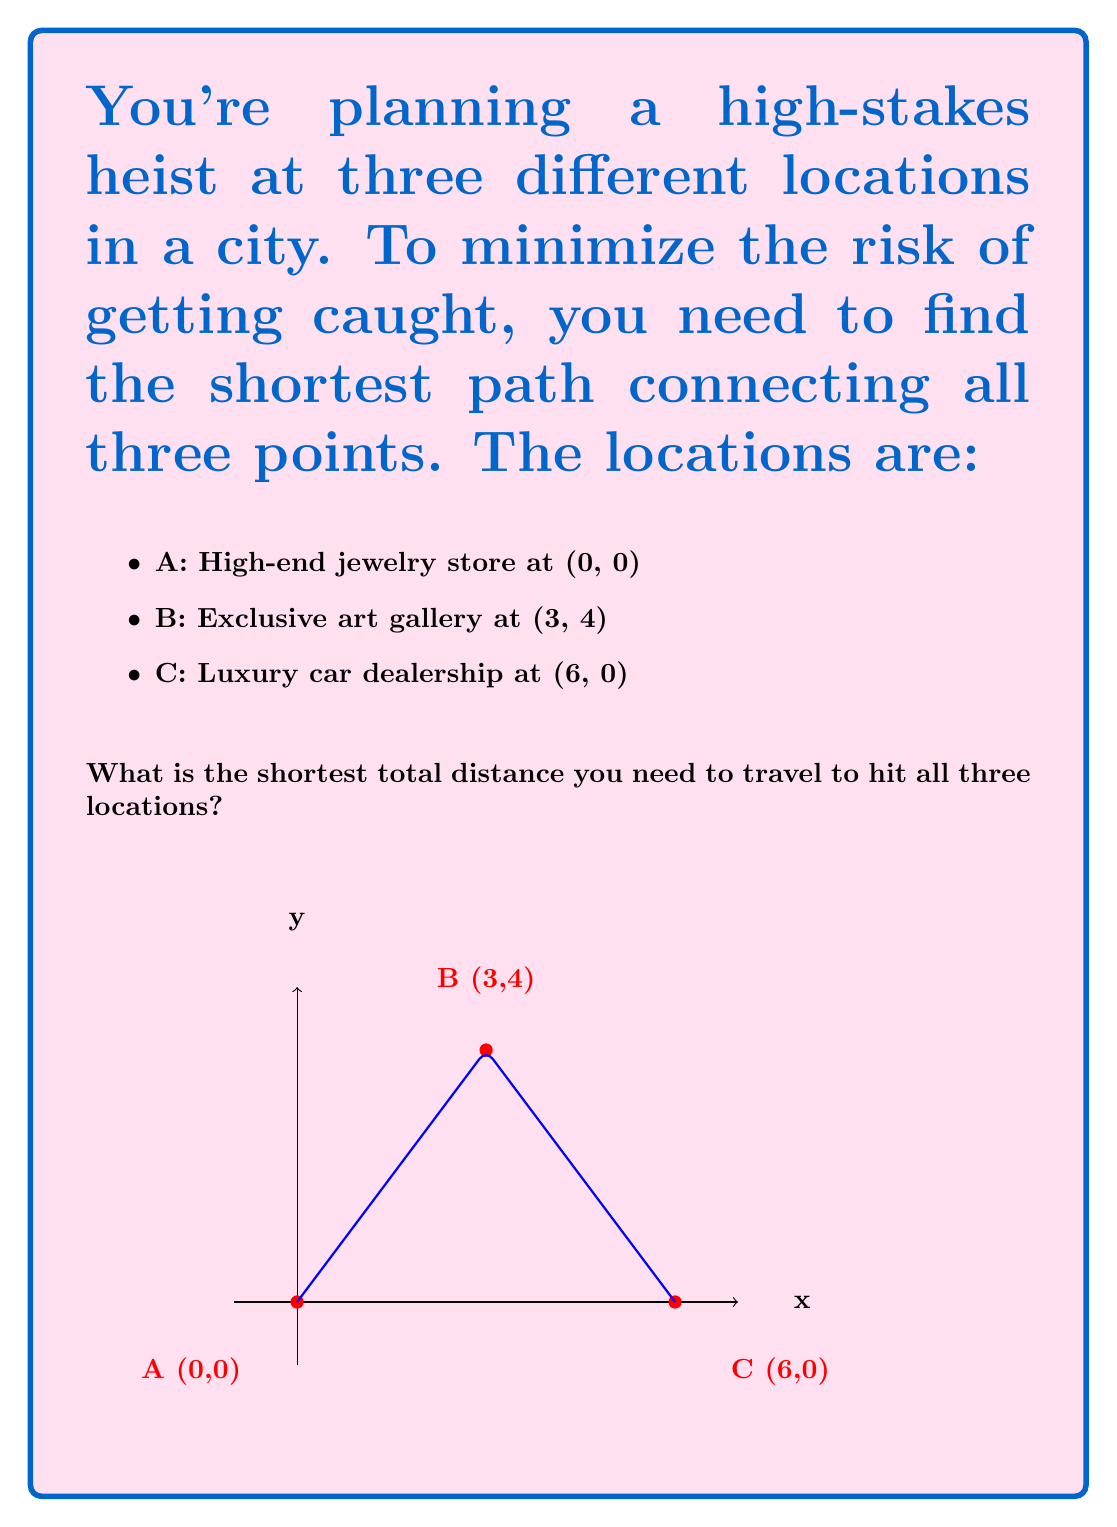Solve this math problem. Let's approach this step-by-step:

1) First, we need to calculate the distances between each pair of points using the distance formula:
   $d = \sqrt{(x_2-x_1)^2 + (y_2-y_1)^2}$

2) Distance AB:
   $AB = \sqrt{(3-0)^2 + (4-0)^2} = \sqrt{9 + 16} = \sqrt{25} = 5$

3) Distance BC:
   $BC = \sqrt{(6-3)^2 + (0-4)^2} = \sqrt{9 + 16} = \sqrt{25} = 5$

4) Distance AC:
   $AC = \sqrt{(6-0)^2 + (0-0)^2} = \sqrt{36 + 0} = 6$

5) Now, we need to find the shortest path that connects all three points. There are three possible routes:
   - A → B → C
   - A → C → B
   - B → A → C

6) The lengths of these routes are:
   - A → B → C: 5 + 5 = 10
   - A → C → B: 6 + 5 = 11
   - B → A → C: 5 + 6 = 11

7) The shortest path is A → B → C, with a total length of 10 units.
Answer: 10 units 